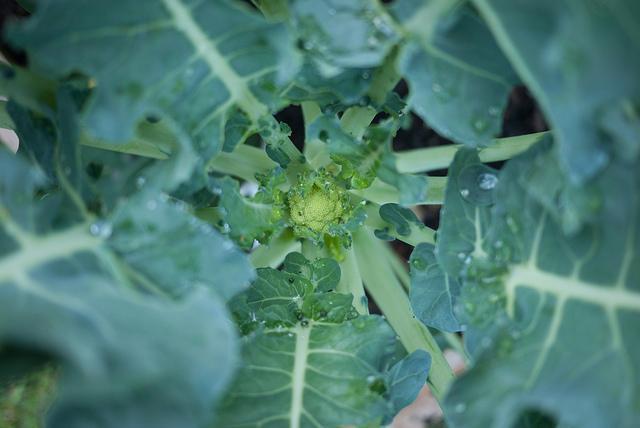How many buses are there?
Give a very brief answer. 0. 